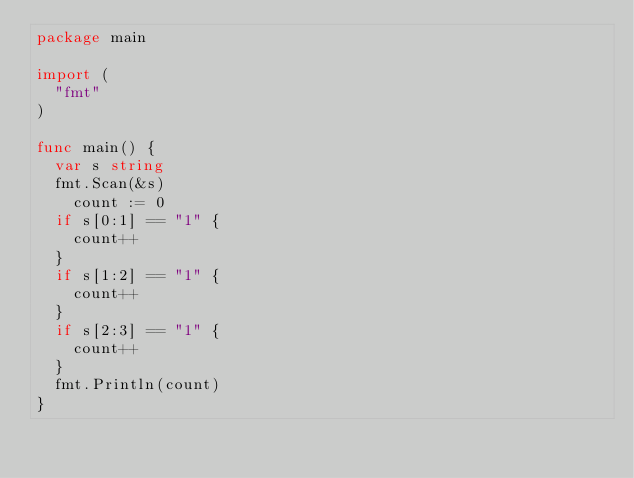Convert code to text. <code><loc_0><loc_0><loc_500><loc_500><_Go_>package main
 
import (
	"fmt"
)
 
func main() {
	var s string
	fmt.Scan(&s)
    count := 0
	if s[0:1] == "1" {
		count++
	}
	if s[1:2] == "1" {
		count++
	}
	if s[2:3] == "1" {
		count++
	}
	fmt.Println(count)
}</code> 